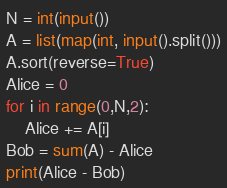<code> <loc_0><loc_0><loc_500><loc_500><_Python_>N = int(input())
A = list(map(int, input().split()))
A.sort(reverse=True)
Alice = 0
for i in range(0,N,2):
    Alice += A[i]
Bob = sum(A) - Alice
print(Alice - Bob)</code> 